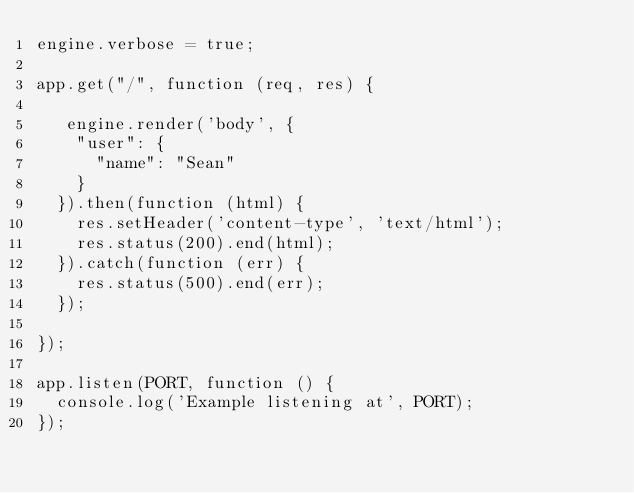<code> <loc_0><loc_0><loc_500><loc_500><_JavaScript_>engine.verbose = true;

app.get("/", function (req, res) {
  
   engine.render('body', {
    "user": {
      "name": "Sean"
    }
  }).then(function (html) {
    res.setHeader('content-type', 'text/html');
    res.status(200).end(html);
  }).catch(function (err) {
    res.status(500).end(err);
  });
  
});

app.listen(PORT, function () {
  console.log('Example listening at', PORT);
});</code> 